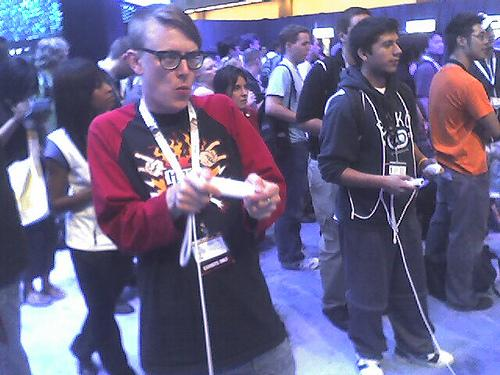What are the people in the front holding? Please explain your reasoning. controllers. The people have controllers. 